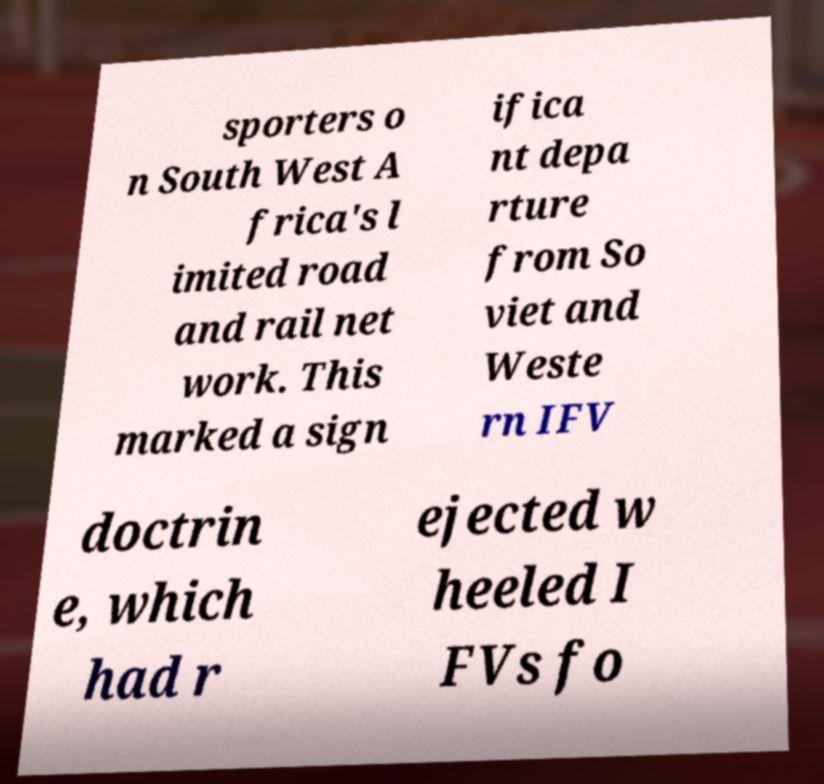Please read and relay the text visible in this image. What does it say? sporters o n South West A frica's l imited road and rail net work. This marked a sign ifica nt depa rture from So viet and Weste rn IFV doctrin e, which had r ejected w heeled I FVs fo 